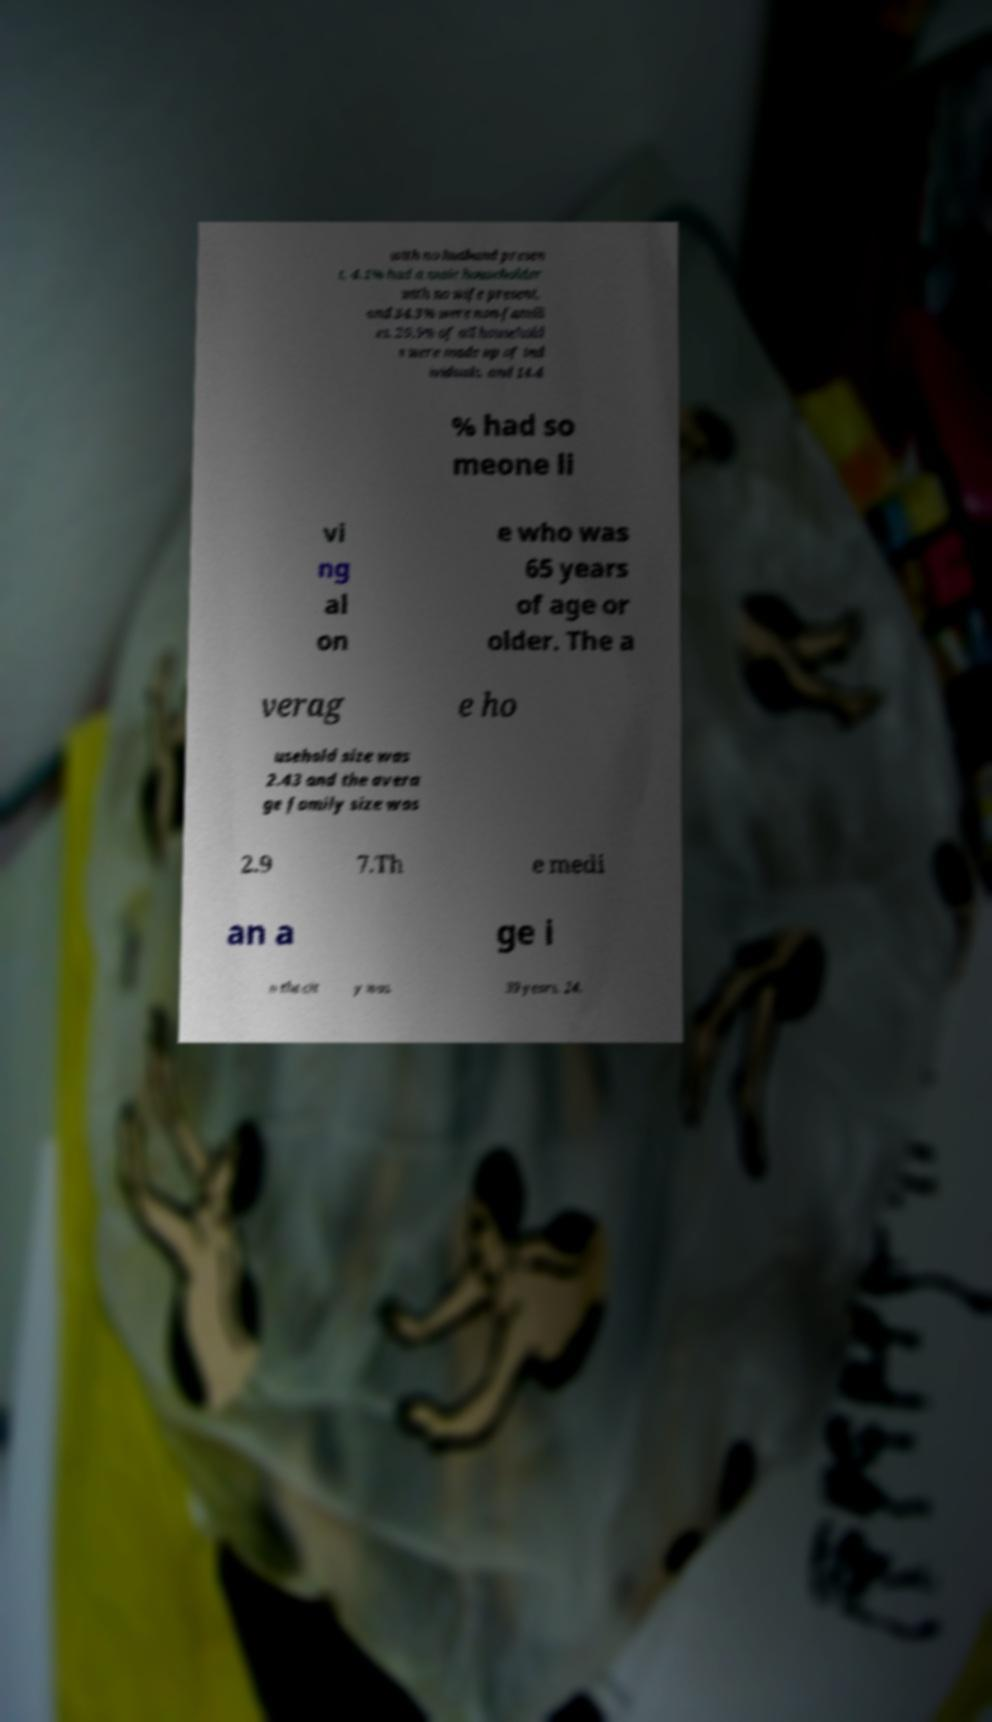Please read and relay the text visible in this image. What does it say? with no husband presen t, 4.1% had a male householder with no wife present, and 34.3% were non-famili es. 29.5% of all household s were made up of ind ividuals, and 14.4 % had so meone li vi ng al on e who was 65 years of age or older. The a verag e ho usehold size was 2.43 and the avera ge family size was 2.9 7.Th e medi an a ge i n the cit y was 39 years. 24. 